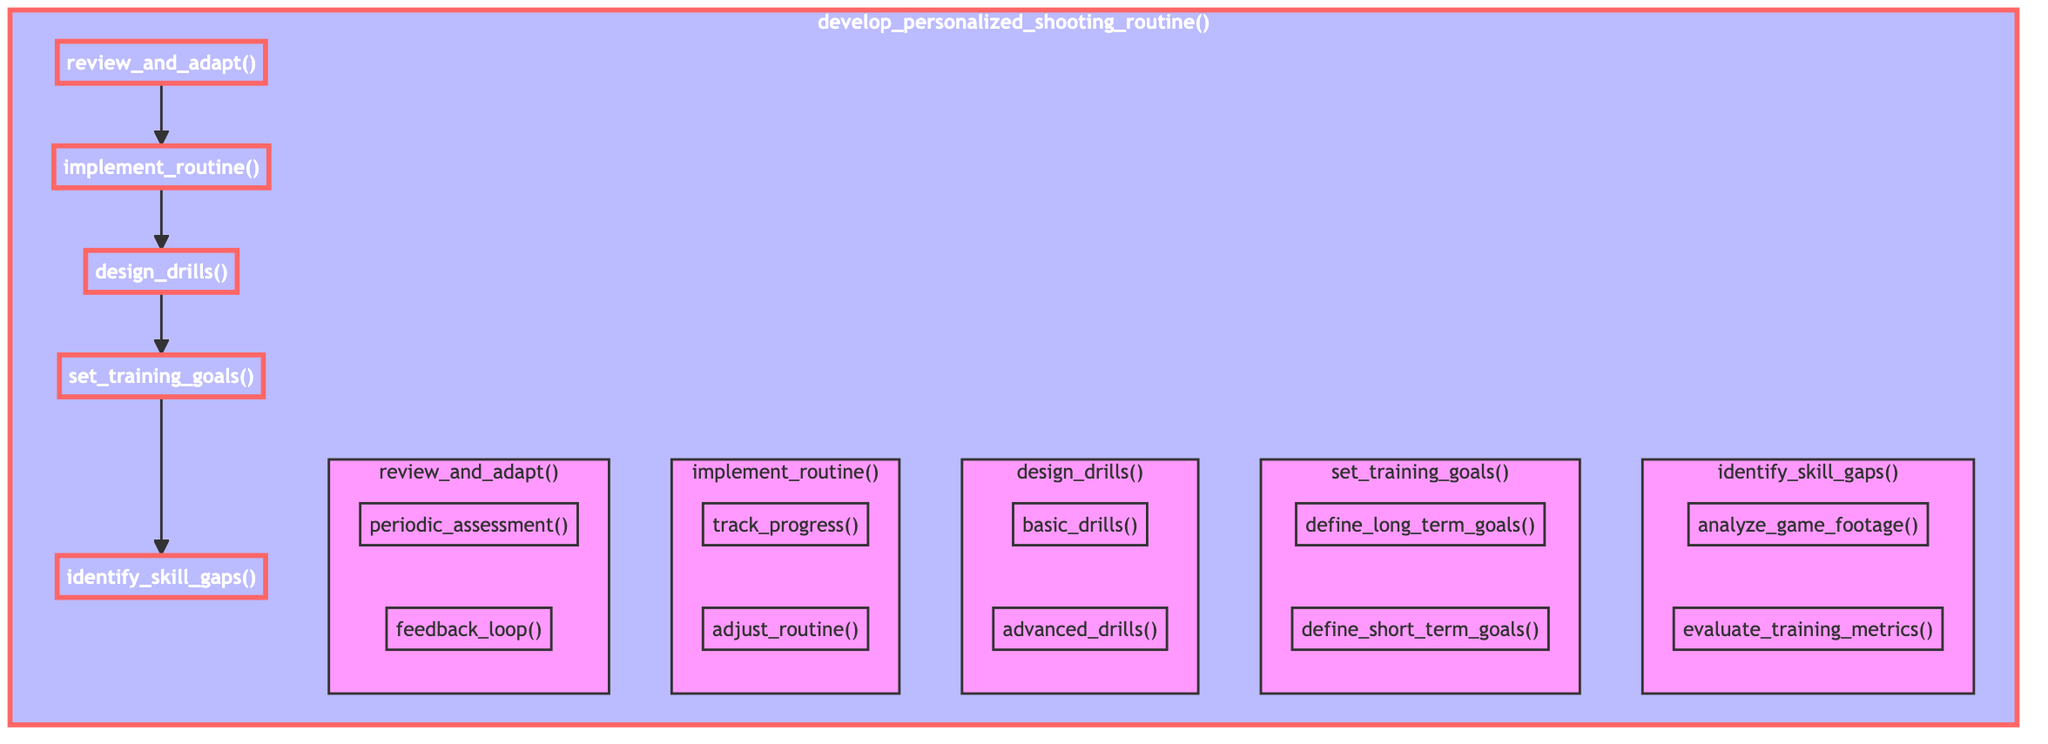What is the first step in the personalized shooting routine process? The first step in the flowchart, flowing from bottom to up, is "identify_skill_gaps." This is depicted as the bottom node that connects to "set_training_goals," indicating it is the starting point of the routine.
Answer: identify skill gaps How many main functions are shown in the diagram? The diagram shows five main functions: "identify_skill_gaps," "set_training_goals," "design_drills," "implement_routine," and "review_and_adapt." These functions are connected in a flowchart format, illustrating their relationship.
Answer: five What are the two components of "review_and_adapt"? Within the "review_and_adapt" function, there are two components shown: "periodic_assessment" and "feedback_loop." These elements are indicated as subsections under the main function in the flowchart.
Answer: periodic assessment and feedback loop Which function directly precedes "implement_routine"? The function that directly precedes "implement_routine" in the flowchart is "review_and_adapt." This indicates that after reviewing and adapting, the next step is to implement the routine.
Answer: review and adapt How often should progress be tracked according to the flowchart? The flowchart indicates tracking progress continuously during training sessions as part of the "implement_routine" function. The term "regularly" suggests an ongoing effort, rather than a specific timeframe.
Answer: regularly What is the relationship between "set_training_goals" and "design_drills"? The relationship depicted in the flowchart indicates that "set_training_goals" comes before "design_drills," suggesting that goals must be established prior to creating specific drills to address those goals.
Answer: one comes before the other What type of drills are included under "design_drills"? Under "design_drills," there are two types of drills specified: "basic_drills" and "advanced_drills." This division indicates a progression from foundational to more challenging drills in the training routine.
Answer: basic drills and advanced drills Which element involves evaluating training data? The element that involves evaluating training data is "evaluate_training_metrics," which is a child node of "identify_skill_gaps," illustrating the process of identifying areas of improvement in shooting technique.
Answer: evaluate training metrics What is the purpose of "feedback_loop"? The "feedback_loop" ensures continuous improvement by refining the shooting routine based on real-world results from the player's performance, as shown under the "review_and_adapt" process.
Answer: refine routine based on results 